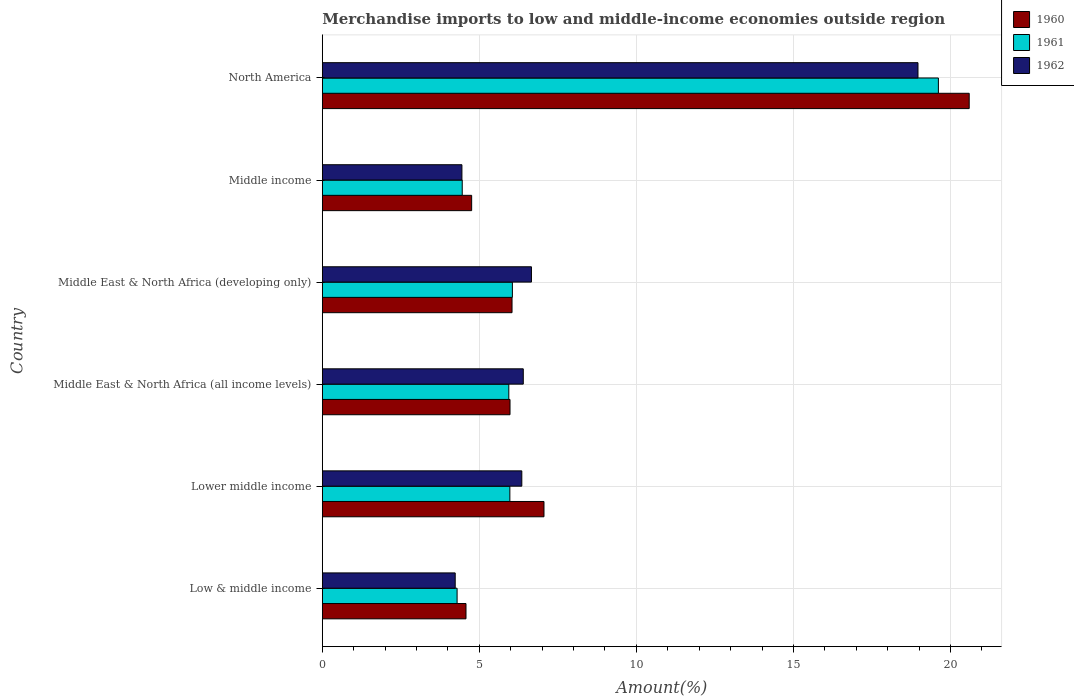How many groups of bars are there?
Provide a short and direct response. 6. Are the number of bars on each tick of the Y-axis equal?
Offer a very short reply. Yes. How many bars are there on the 1st tick from the top?
Make the answer very short. 3. How many bars are there on the 1st tick from the bottom?
Provide a succinct answer. 3. What is the label of the 6th group of bars from the top?
Provide a succinct answer. Low & middle income. What is the percentage of amount earned from merchandise imports in 1961 in Lower middle income?
Give a very brief answer. 5.97. Across all countries, what is the maximum percentage of amount earned from merchandise imports in 1962?
Ensure brevity in your answer.  18.97. Across all countries, what is the minimum percentage of amount earned from merchandise imports in 1960?
Make the answer very short. 4.57. In which country was the percentage of amount earned from merchandise imports in 1960 maximum?
Give a very brief answer. North America. What is the total percentage of amount earned from merchandise imports in 1962 in the graph?
Offer a terse response. 47.05. What is the difference between the percentage of amount earned from merchandise imports in 1962 in Middle East & North Africa (all income levels) and that in North America?
Ensure brevity in your answer.  -12.57. What is the difference between the percentage of amount earned from merchandise imports in 1960 in North America and the percentage of amount earned from merchandise imports in 1961 in Middle East & North Africa (developing only)?
Keep it short and to the point. 14.55. What is the average percentage of amount earned from merchandise imports in 1962 per country?
Ensure brevity in your answer.  7.84. What is the difference between the percentage of amount earned from merchandise imports in 1961 and percentage of amount earned from merchandise imports in 1960 in Middle East & North Africa (all income levels)?
Ensure brevity in your answer.  -0.04. What is the ratio of the percentage of amount earned from merchandise imports in 1962 in Middle East & North Africa (all income levels) to that in Middle income?
Your response must be concise. 1.44. Is the percentage of amount earned from merchandise imports in 1961 in Low & middle income less than that in Middle East & North Africa (developing only)?
Make the answer very short. Yes. What is the difference between the highest and the second highest percentage of amount earned from merchandise imports in 1961?
Give a very brief answer. 13.56. What is the difference between the highest and the lowest percentage of amount earned from merchandise imports in 1961?
Provide a succinct answer. 15.33. In how many countries, is the percentage of amount earned from merchandise imports in 1961 greater than the average percentage of amount earned from merchandise imports in 1961 taken over all countries?
Your response must be concise. 1. What does the 1st bar from the bottom in Low & middle income represents?
Offer a very short reply. 1960. Is it the case that in every country, the sum of the percentage of amount earned from merchandise imports in 1960 and percentage of amount earned from merchandise imports in 1961 is greater than the percentage of amount earned from merchandise imports in 1962?
Your answer should be compact. Yes. How many bars are there?
Offer a very short reply. 18. Are all the bars in the graph horizontal?
Keep it short and to the point. Yes. What is the difference between two consecutive major ticks on the X-axis?
Your response must be concise. 5. Does the graph contain any zero values?
Give a very brief answer. No. Does the graph contain grids?
Offer a terse response. Yes. How many legend labels are there?
Ensure brevity in your answer.  3. What is the title of the graph?
Provide a short and direct response. Merchandise imports to low and middle-income economies outside region. What is the label or title of the X-axis?
Offer a very short reply. Amount(%). What is the Amount(%) in 1960 in Low & middle income?
Your response must be concise. 4.57. What is the Amount(%) of 1961 in Low & middle income?
Make the answer very short. 4.29. What is the Amount(%) of 1962 in Low & middle income?
Offer a very short reply. 4.23. What is the Amount(%) of 1960 in Lower middle income?
Ensure brevity in your answer.  7.06. What is the Amount(%) in 1961 in Lower middle income?
Your response must be concise. 5.97. What is the Amount(%) of 1962 in Lower middle income?
Your answer should be very brief. 6.35. What is the Amount(%) of 1960 in Middle East & North Africa (all income levels)?
Provide a short and direct response. 5.98. What is the Amount(%) of 1961 in Middle East & North Africa (all income levels)?
Your answer should be compact. 5.94. What is the Amount(%) in 1962 in Middle East & North Africa (all income levels)?
Provide a succinct answer. 6.4. What is the Amount(%) in 1960 in Middle East & North Africa (developing only)?
Ensure brevity in your answer.  6.04. What is the Amount(%) in 1961 in Middle East & North Africa (developing only)?
Offer a terse response. 6.05. What is the Amount(%) of 1962 in Middle East & North Africa (developing only)?
Your answer should be very brief. 6.66. What is the Amount(%) in 1960 in Middle income?
Provide a short and direct response. 4.75. What is the Amount(%) in 1961 in Middle income?
Provide a succinct answer. 4.45. What is the Amount(%) in 1962 in Middle income?
Give a very brief answer. 4.44. What is the Amount(%) of 1960 in North America?
Keep it short and to the point. 20.6. What is the Amount(%) of 1961 in North America?
Offer a very short reply. 19.62. What is the Amount(%) in 1962 in North America?
Make the answer very short. 18.97. Across all countries, what is the maximum Amount(%) of 1960?
Provide a succinct answer. 20.6. Across all countries, what is the maximum Amount(%) of 1961?
Provide a short and direct response. 19.62. Across all countries, what is the maximum Amount(%) of 1962?
Provide a short and direct response. 18.97. Across all countries, what is the minimum Amount(%) of 1960?
Give a very brief answer. 4.57. Across all countries, what is the minimum Amount(%) in 1961?
Ensure brevity in your answer.  4.29. Across all countries, what is the minimum Amount(%) of 1962?
Provide a short and direct response. 4.23. What is the total Amount(%) in 1960 in the graph?
Offer a terse response. 49. What is the total Amount(%) of 1961 in the graph?
Offer a terse response. 46.32. What is the total Amount(%) in 1962 in the graph?
Your answer should be compact. 47.05. What is the difference between the Amount(%) of 1960 in Low & middle income and that in Lower middle income?
Give a very brief answer. -2.48. What is the difference between the Amount(%) in 1961 in Low & middle income and that in Lower middle income?
Your answer should be very brief. -1.68. What is the difference between the Amount(%) in 1962 in Low & middle income and that in Lower middle income?
Your answer should be very brief. -2.12. What is the difference between the Amount(%) in 1960 in Low & middle income and that in Middle East & North Africa (all income levels)?
Your answer should be compact. -1.4. What is the difference between the Amount(%) of 1961 in Low & middle income and that in Middle East & North Africa (all income levels)?
Provide a short and direct response. -1.65. What is the difference between the Amount(%) of 1962 in Low & middle income and that in Middle East & North Africa (all income levels)?
Keep it short and to the point. -2.17. What is the difference between the Amount(%) of 1960 in Low & middle income and that in Middle East & North Africa (developing only)?
Offer a very short reply. -1.47. What is the difference between the Amount(%) of 1961 in Low & middle income and that in Middle East & North Africa (developing only)?
Offer a terse response. -1.76. What is the difference between the Amount(%) in 1962 in Low & middle income and that in Middle East & North Africa (developing only)?
Provide a short and direct response. -2.43. What is the difference between the Amount(%) in 1960 in Low & middle income and that in Middle income?
Offer a terse response. -0.18. What is the difference between the Amount(%) in 1961 in Low & middle income and that in Middle income?
Offer a very short reply. -0.16. What is the difference between the Amount(%) of 1962 in Low & middle income and that in Middle income?
Your answer should be very brief. -0.21. What is the difference between the Amount(%) of 1960 in Low & middle income and that in North America?
Make the answer very short. -16.02. What is the difference between the Amount(%) of 1961 in Low & middle income and that in North America?
Make the answer very short. -15.33. What is the difference between the Amount(%) in 1962 in Low & middle income and that in North America?
Your answer should be compact. -14.73. What is the difference between the Amount(%) of 1960 in Lower middle income and that in Middle East & North Africa (all income levels)?
Provide a short and direct response. 1.08. What is the difference between the Amount(%) in 1961 in Lower middle income and that in Middle East & North Africa (all income levels)?
Offer a very short reply. 0.03. What is the difference between the Amount(%) in 1962 in Lower middle income and that in Middle East & North Africa (all income levels)?
Your response must be concise. -0.05. What is the difference between the Amount(%) of 1960 in Lower middle income and that in Middle East & North Africa (developing only)?
Give a very brief answer. 1.02. What is the difference between the Amount(%) in 1961 in Lower middle income and that in Middle East & North Africa (developing only)?
Keep it short and to the point. -0.08. What is the difference between the Amount(%) in 1962 in Lower middle income and that in Middle East & North Africa (developing only)?
Your answer should be very brief. -0.31. What is the difference between the Amount(%) in 1960 in Lower middle income and that in Middle income?
Keep it short and to the point. 2.3. What is the difference between the Amount(%) in 1961 in Lower middle income and that in Middle income?
Your answer should be very brief. 1.52. What is the difference between the Amount(%) of 1962 in Lower middle income and that in Middle income?
Provide a succinct answer. 1.91. What is the difference between the Amount(%) in 1960 in Lower middle income and that in North America?
Ensure brevity in your answer.  -13.54. What is the difference between the Amount(%) of 1961 in Lower middle income and that in North America?
Offer a terse response. -13.64. What is the difference between the Amount(%) of 1962 in Lower middle income and that in North America?
Provide a succinct answer. -12.61. What is the difference between the Amount(%) of 1960 in Middle East & North Africa (all income levels) and that in Middle East & North Africa (developing only)?
Keep it short and to the point. -0.06. What is the difference between the Amount(%) in 1961 in Middle East & North Africa (all income levels) and that in Middle East & North Africa (developing only)?
Keep it short and to the point. -0.11. What is the difference between the Amount(%) of 1962 in Middle East & North Africa (all income levels) and that in Middle East & North Africa (developing only)?
Offer a very short reply. -0.26. What is the difference between the Amount(%) in 1960 in Middle East & North Africa (all income levels) and that in Middle income?
Offer a terse response. 1.22. What is the difference between the Amount(%) of 1961 in Middle East & North Africa (all income levels) and that in Middle income?
Offer a terse response. 1.48. What is the difference between the Amount(%) in 1962 in Middle East & North Africa (all income levels) and that in Middle income?
Your answer should be very brief. 1.95. What is the difference between the Amount(%) in 1960 in Middle East & North Africa (all income levels) and that in North America?
Make the answer very short. -14.62. What is the difference between the Amount(%) of 1961 in Middle East & North Africa (all income levels) and that in North America?
Provide a succinct answer. -13.68. What is the difference between the Amount(%) in 1962 in Middle East & North Africa (all income levels) and that in North America?
Give a very brief answer. -12.57. What is the difference between the Amount(%) in 1960 in Middle East & North Africa (developing only) and that in Middle income?
Your answer should be compact. 1.29. What is the difference between the Amount(%) in 1961 in Middle East & North Africa (developing only) and that in Middle income?
Offer a terse response. 1.6. What is the difference between the Amount(%) in 1962 in Middle East & North Africa (developing only) and that in Middle income?
Offer a very short reply. 2.21. What is the difference between the Amount(%) of 1960 in Middle East & North Africa (developing only) and that in North America?
Keep it short and to the point. -14.56. What is the difference between the Amount(%) of 1961 in Middle East & North Africa (developing only) and that in North America?
Offer a very short reply. -13.56. What is the difference between the Amount(%) in 1962 in Middle East & North Africa (developing only) and that in North America?
Provide a short and direct response. -12.31. What is the difference between the Amount(%) of 1960 in Middle income and that in North America?
Keep it short and to the point. -15.84. What is the difference between the Amount(%) of 1961 in Middle income and that in North America?
Ensure brevity in your answer.  -15.16. What is the difference between the Amount(%) of 1962 in Middle income and that in North America?
Your answer should be compact. -14.52. What is the difference between the Amount(%) in 1960 in Low & middle income and the Amount(%) in 1961 in Lower middle income?
Give a very brief answer. -1.4. What is the difference between the Amount(%) in 1960 in Low & middle income and the Amount(%) in 1962 in Lower middle income?
Ensure brevity in your answer.  -1.78. What is the difference between the Amount(%) in 1961 in Low & middle income and the Amount(%) in 1962 in Lower middle income?
Your response must be concise. -2.06. What is the difference between the Amount(%) of 1960 in Low & middle income and the Amount(%) of 1961 in Middle East & North Africa (all income levels)?
Provide a succinct answer. -1.36. What is the difference between the Amount(%) in 1960 in Low & middle income and the Amount(%) in 1962 in Middle East & North Africa (all income levels)?
Offer a very short reply. -1.82. What is the difference between the Amount(%) in 1961 in Low & middle income and the Amount(%) in 1962 in Middle East & North Africa (all income levels)?
Your answer should be compact. -2.11. What is the difference between the Amount(%) of 1960 in Low & middle income and the Amount(%) of 1961 in Middle East & North Africa (developing only)?
Provide a succinct answer. -1.48. What is the difference between the Amount(%) of 1960 in Low & middle income and the Amount(%) of 1962 in Middle East & North Africa (developing only)?
Your response must be concise. -2.08. What is the difference between the Amount(%) in 1961 in Low & middle income and the Amount(%) in 1962 in Middle East & North Africa (developing only)?
Ensure brevity in your answer.  -2.37. What is the difference between the Amount(%) in 1960 in Low & middle income and the Amount(%) in 1961 in Middle income?
Make the answer very short. 0.12. What is the difference between the Amount(%) in 1960 in Low & middle income and the Amount(%) in 1962 in Middle income?
Ensure brevity in your answer.  0.13. What is the difference between the Amount(%) in 1961 in Low & middle income and the Amount(%) in 1962 in Middle income?
Make the answer very short. -0.15. What is the difference between the Amount(%) of 1960 in Low & middle income and the Amount(%) of 1961 in North America?
Make the answer very short. -15.04. What is the difference between the Amount(%) in 1960 in Low & middle income and the Amount(%) in 1962 in North America?
Give a very brief answer. -14.39. What is the difference between the Amount(%) in 1961 in Low & middle income and the Amount(%) in 1962 in North America?
Your response must be concise. -14.68. What is the difference between the Amount(%) in 1960 in Lower middle income and the Amount(%) in 1961 in Middle East & North Africa (all income levels)?
Offer a very short reply. 1.12. What is the difference between the Amount(%) in 1960 in Lower middle income and the Amount(%) in 1962 in Middle East & North Africa (all income levels)?
Your answer should be very brief. 0.66. What is the difference between the Amount(%) in 1961 in Lower middle income and the Amount(%) in 1962 in Middle East & North Africa (all income levels)?
Ensure brevity in your answer.  -0.43. What is the difference between the Amount(%) in 1960 in Lower middle income and the Amount(%) in 1961 in Middle East & North Africa (developing only)?
Offer a terse response. 1.01. What is the difference between the Amount(%) in 1960 in Lower middle income and the Amount(%) in 1962 in Middle East & North Africa (developing only)?
Make the answer very short. 0.4. What is the difference between the Amount(%) of 1961 in Lower middle income and the Amount(%) of 1962 in Middle East & North Africa (developing only)?
Make the answer very short. -0.69. What is the difference between the Amount(%) in 1960 in Lower middle income and the Amount(%) in 1961 in Middle income?
Keep it short and to the point. 2.6. What is the difference between the Amount(%) of 1960 in Lower middle income and the Amount(%) of 1962 in Middle income?
Provide a short and direct response. 2.61. What is the difference between the Amount(%) in 1961 in Lower middle income and the Amount(%) in 1962 in Middle income?
Make the answer very short. 1.53. What is the difference between the Amount(%) of 1960 in Lower middle income and the Amount(%) of 1961 in North America?
Provide a short and direct response. -12.56. What is the difference between the Amount(%) in 1960 in Lower middle income and the Amount(%) in 1962 in North America?
Ensure brevity in your answer.  -11.91. What is the difference between the Amount(%) of 1961 in Lower middle income and the Amount(%) of 1962 in North America?
Make the answer very short. -12.99. What is the difference between the Amount(%) in 1960 in Middle East & North Africa (all income levels) and the Amount(%) in 1961 in Middle East & North Africa (developing only)?
Make the answer very short. -0.08. What is the difference between the Amount(%) of 1960 in Middle East & North Africa (all income levels) and the Amount(%) of 1962 in Middle East & North Africa (developing only)?
Ensure brevity in your answer.  -0.68. What is the difference between the Amount(%) in 1961 in Middle East & North Africa (all income levels) and the Amount(%) in 1962 in Middle East & North Africa (developing only)?
Give a very brief answer. -0.72. What is the difference between the Amount(%) of 1960 in Middle East & North Africa (all income levels) and the Amount(%) of 1961 in Middle income?
Provide a succinct answer. 1.52. What is the difference between the Amount(%) in 1960 in Middle East & North Africa (all income levels) and the Amount(%) in 1962 in Middle income?
Offer a very short reply. 1.53. What is the difference between the Amount(%) of 1961 in Middle East & North Africa (all income levels) and the Amount(%) of 1962 in Middle income?
Make the answer very short. 1.49. What is the difference between the Amount(%) in 1960 in Middle East & North Africa (all income levels) and the Amount(%) in 1961 in North America?
Your answer should be compact. -13.64. What is the difference between the Amount(%) of 1960 in Middle East & North Africa (all income levels) and the Amount(%) of 1962 in North America?
Your response must be concise. -12.99. What is the difference between the Amount(%) in 1961 in Middle East & North Africa (all income levels) and the Amount(%) in 1962 in North America?
Provide a succinct answer. -13.03. What is the difference between the Amount(%) of 1960 in Middle East & North Africa (developing only) and the Amount(%) of 1961 in Middle income?
Make the answer very short. 1.59. What is the difference between the Amount(%) in 1960 in Middle East & North Africa (developing only) and the Amount(%) in 1962 in Middle income?
Provide a succinct answer. 1.6. What is the difference between the Amount(%) of 1961 in Middle East & North Africa (developing only) and the Amount(%) of 1962 in Middle income?
Provide a short and direct response. 1.61. What is the difference between the Amount(%) of 1960 in Middle East & North Africa (developing only) and the Amount(%) of 1961 in North America?
Provide a short and direct response. -13.58. What is the difference between the Amount(%) of 1960 in Middle East & North Africa (developing only) and the Amount(%) of 1962 in North America?
Make the answer very short. -12.93. What is the difference between the Amount(%) of 1961 in Middle East & North Africa (developing only) and the Amount(%) of 1962 in North America?
Offer a terse response. -12.91. What is the difference between the Amount(%) in 1960 in Middle income and the Amount(%) in 1961 in North America?
Your answer should be very brief. -14.86. What is the difference between the Amount(%) of 1960 in Middle income and the Amount(%) of 1962 in North America?
Provide a succinct answer. -14.21. What is the difference between the Amount(%) in 1961 in Middle income and the Amount(%) in 1962 in North America?
Keep it short and to the point. -14.51. What is the average Amount(%) in 1960 per country?
Your answer should be compact. 8.17. What is the average Amount(%) of 1961 per country?
Your response must be concise. 7.72. What is the average Amount(%) of 1962 per country?
Your answer should be very brief. 7.84. What is the difference between the Amount(%) of 1960 and Amount(%) of 1961 in Low & middle income?
Keep it short and to the point. 0.28. What is the difference between the Amount(%) of 1960 and Amount(%) of 1962 in Low & middle income?
Your answer should be very brief. 0.34. What is the difference between the Amount(%) in 1961 and Amount(%) in 1962 in Low & middle income?
Keep it short and to the point. 0.06. What is the difference between the Amount(%) of 1960 and Amount(%) of 1961 in Lower middle income?
Give a very brief answer. 1.09. What is the difference between the Amount(%) in 1960 and Amount(%) in 1962 in Lower middle income?
Ensure brevity in your answer.  0.71. What is the difference between the Amount(%) of 1961 and Amount(%) of 1962 in Lower middle income?
Keep it short and to the point. -0.38. What is the difference between the Amount(%) of 1960 and Amount(%) of 1961 in Middle East & North Africa (all income levels)?
Give a very brief answer. 0.04. What is the difference between the Amount(%) of 1960 and Amount(%) of 1962 in Middle East & North Africa (all income levels)?
Your answer should be compact. -0.42. What is the difference between the Amount(%) in 1961 and Amount(%) in 1962 in Middle East & North Africa (all income levels)?
Offer a terse response. -0.46. What is the difference between the Amount(%) in 1960 and Amount(%) in 1961 in Middle East & North Africa (developing only)?
Offer a very short reply. -0.01. What is the difference between the Amount(%) in 1960 and Amount(%) in 1962 in Middle East & North Africa (developing only)?
Offer a very short reply. -0.62. What is the difference between the Amount(%) of 1961 and Amount(%) of 1962 in Middle East & North Africa (developing only)?
Give a very brief answer. -0.61. What is the difference between the Amount(%) in 1960 and Amount(%) in 1961 in Middle income?
Offer a very short reply. 0.3. What is the difference between the Amount(%) of 1960 and Amount(%) of 1962 in Middle income?
Ensure brevity in your answer.  0.31. What is the difference between the Amount(%) in 1961 and Amount(%) in 1962 in Middle income?
Keep it short and to the point. 0.01. What is the difference between the Amount(%) in 1960 and Amount(%) in 1961 in North America?
Ensure brevity in your answer.  0.98. What is the difference between the Amount(%) of 1960 and Amount(%) of 1962 in North America?
Your answer should be compact. 1.63. What is the difference between the Amount(%) of 1961 and Amount(%) of 1962 in North America?
Provide a short and direct response. 0.65. What is the ratio of the Amount(%) in 1960 in Low & middle income to that in Lower middle income?
Your answer should be very brief. 0.65. What is the ratio of the Amount(%) in 1961 in Low & middle income to that in Lower middle income?
Offer a very short reply. 0.72. What is the ratio of the Amount(%) in 1962 in Low & middle income to that in Lower middle income?
Your answer should be very brief. 0.67. What is the ratio of the Amount(%) of 1960 in Low & middle income to that in Middle East & North Africa (all income levels)?
Keep it short and to the point. 0.77. What is the ratio of the Amount(%) in 1961 in Low & middle income to that in Middle East & North Africa (all income levels)?
Your response must be concise. 0.72. What is the ratio of the Amount(%) of 1962 in Low & middle income to that in Middle East & North Africa (all income levels)?
Provide a succinct answer. 0.66. What is the ratio of the Amount(%) of 1960 in Low & middle income to that in Middle East & North Africa (developing only)?
Give a very brief answer. 0.76. What is the ratio of the Amount(%) in 1961 in Low & middle income to that in Middle East & North Africa (developing only)?
Your answer should be very brief. 0.71. What is the ratio of the Amount(%) in 1962 in Low & middle income to that in Middle East & North Africa (developing only)?
Your response must be concise. 0.64. What is the ratio of the Amount(%) in 1960 in Low & middle income to that in Middle income?
Your answer should be compact. 0.96. What is the ratio of the Amount(%) in 1961 in Low & middle income to that in Middle income?
Ensure brevity in your answer.  0.96. What is the ratio of the Amount(%) of 1962 in Low & middle income to that in Middle income?
Offer a terse response. 0.95. What is the ratio of the Amount(%) in 1960 in Low & middle income to that in North America?
Offer a terse response. 0.22. What is the ratio of the Amount(%) in 1961 in Low & middle income to that in North America?
Provide a short and direct response. 0.22. What is the ratio of the Amount(%) of 1962 in Low & middle income to that in North America?
Give a very brief answer. 0.22. What is the ratio of the Amount(%) of 1960 in Lower middle income to that in Middle East & North Africa (all income levels)?
Offer a terse response. 1.18. What is the ratio of the Amount(%) of 1961 in Lower middle income to that in Middle East & North Africa (all income levels)?
Make the answer very short. 1.01. What is the ratio of the Amount(%) in 1960 in Lower middle income to that in Middle East & North Africa (developing only)?
Your response must be concise. 1.17. What is the ratio of the Amount(%) in 1961 in Lower middle income to that in Middle East & North Africa (developing only)?
Keep it short and to the point. 0.99. What is the ratio of the Amount(%) of 1962 in Lower middle income to that in Middle East & North Africa (developing only)?
Ensure brevity in your answer.  0.95. What is the ratio of the Amount(%) of 1960 in Lower middle income to that in Middle income?
Provide a short and direct response. 1.48. What is the ratio of the Amount(%) in 1961 in Lower middle income to that in Middle income?
Keep it short and to the point. 1.34. What is the ratio of the Amount(%) of 1962 in Lower middle income to that in Middle income?
Keep it short and to the point. 1.43. What is the ratio of the Amount(%) in 1960 in Lower middle income to that in North America?
Your answer should be very brief. 0.34. What is the ratio of the Amount(%) of 1961 in Lower middle income to that in North America?
Your response must be concise. 0.3. What is the ratio of the Amount(%) of 1962 in Lower middle income to that in North America?
Offer a terse response. 0.33. What is the ratio of the Amount(%) in 1960 in Middle East & North Africa (all income levels) to that in Middle East & North Africa (developing only)?
Make the answer very short. 0.99. What is the ratio of the Amount(%) of 1961 in Middle East & North Africa (all income levels) to that in Middle East & North Africa (developing only)?
Keep it short and to the point. 0.98. What is the ratio of the Amount(%) of 1962 in Middle East & North Africa (all income levels) to that in Middle East & North Africa (developing only)?
Give a very brief answer. 0.96. What is the ratio of the Amount(%) in 1960 in Middle East & North Africa (all income levels) to that in Middle income?
Offer a very short reply. 1.26. What is the ratio of the Amount(%) of 1961 in Middle East & North Africa (all income levels) to that in Middle income?
Your answer should be very brief. 1.33. What is the ratio of the Amount(%) in 1962 in Middle East & North Africa (all income levels) to that in Middle income?
Give a very brief answer. 1.44. What is the ratio of the Amount(%) in 1960 in Middle East & North Africa (all income levels) to that in North America?
Offer a very short reply. 0.29. What is the ratio of the Amount(%) in 1961 in Middle East & North Africa (all income levels) to that in North America?
Your answer should be compact. 0.3. What is the ratio of the Amount(%) in 1962 in Middle East & North Africa (all income levels) to that in North America?
Your answer should be compact. 0.34. What is the ratio of the Amount(%) in 1960 in Middle East & North Africa (developing only) to that in Middle income?
Give a very brief answer. 1.27. What is the ratio of the Amount(%) in 1961 in Middle East & North Africa (developing only) to that in Middle income?
Provide a succinct answer. 1.36. What is the ratio of the Amount(%) of 1962 in Middle East & North Africa (developing only) to that in Middle income?
Make the answer very short. 1.5. What is the ratio of the Amount(%) in 1960 in Middle East & North Africa (developing only) to that in North America?
Offer a terse response. 0.29. What is the ratio of the Amount(%) of 1961 in Middle East & North Africa (developing only) to that in North America?
Offer a very short reply. 0.31. What is the ratio of the Amount(%) in 1962 in Middle East & North Africa (developing only) to that in North America?
Ensure brevity in your answer.  0.35. What is the ratio of the Amount(%) of 1960 in Middle income to that in North America?
Make the answer very short. 0.23. What is the ratio of the Amount(%) of 1961 in Middle income to that in North America?
Provide a short and direct response. 0.23. What is the ratio of the Amount(%) of 1962 in Middle income to that in North America?
Make the answer very short. 0.23. What is the difference between the highest and the second highest Amount(%) of 1960?
Make the answer very short. 13.54. What is the difference between the highest and the second highest Amount(%) of 1961?
Provide a succinct answer. 13.56. What is the difference between the highest and the second highest Amount(%) in 1962?
Give a very brief answer. 12.31. What is the difference between the highest and the lowest Amount(%) of 1960?
Your answer should be very brief. 16.02. What is the difference between the highest and the lowest Amount(%) in 1961?
Provide a succinct answer. 15.33. What is the difference between the highest and the lowest Amount(%) in 1962?
Keep it short and to the point. 14.73. 